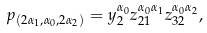<formula> <loc_0><loc_0><loc_500><loc_500>p _ { ( 2 \alpha _ { 1 } , \alpha _ { 0 } , 2 \alpha _ { 2 } ) } = y _ { 2 } ^ { \alpha _ { 0 } } z _ { 2 1 } ^ { \alpha _ { 0 } \alpha _ { 1 } } z _ { 3 2 } ^ { \alpha _ { 0 } \alpha _ { 2 } } ,</formula> 